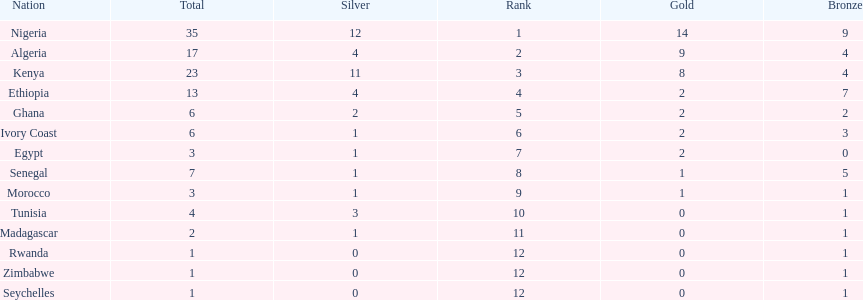The nation above algeria Nigeria. 